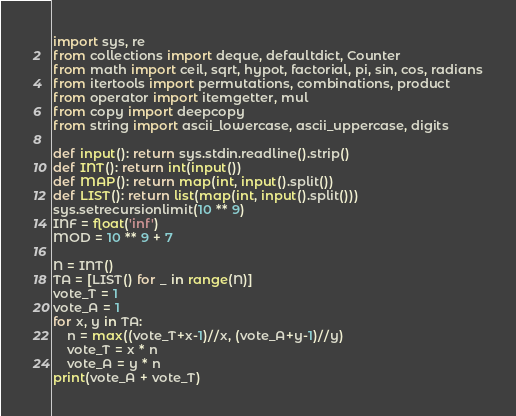Convert code to text. <code><loc_0><loc_0><loc_500><loc_500><_Python_>import sys, re
from collections import deque, defaultdict, Counter
from math import ceil, sqrt, hypot, factorial, pi, sin, cos, radians
from itertools import permutations, combinations, product
from operator import itemgetter, mul
from copy import deepcopy
from string import ascii_lowercase, ascii_uppercase, digits

def input(): return sys.stdin.readline().strip()
def INT(): return int(input())
def MAP(): return map(int, input().split())
def LIST(): return list(map(int, input().split()))
sys.setrecursionlimit(10 ** 9)
INF = float('inf')
MOD = 10 ** 9 + 7

N = INT()
TA = [LIST() for _ in range(N)]
vote_T = 1
vote_A = 1
for x, y in TA:
	n = max((vote_T+x-1)//x, (vote_A+y-1)//y)
	vote_T = x * n
	vote_A = y * n
print(vote_A + vote_T)
</code> 